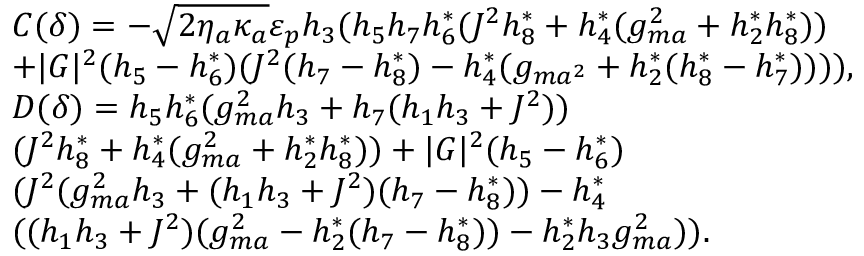<formula> <loc_0><loc_0><loc_500><loc_500>\begin{array} { r l } & { C ( \delta ) = - \sqrt { 2 \eta _ { a } \kappa _ { a } } \varepsilon _ { p } h _ { 3 } ( h _ { 5 } h _ { 7 } h _ { 6 } ^ { * } ( J ^ { 2 } h _ { 8 } ^ { * } + h _ { 4 } ^ { * } ( g _ { m a } ^ { 2 } + h _ { 2 } ^ { * } h _ { 8 } ^ { * } ) ) } \\ & { + | G | ^ { 2 } ( h _ { 5 } - h _ { 6 } ^ { * } ) ( J ^ { 2 } ( h _ { 7 } - h _ { 8 } ^ { * } ) - h _ { 4 } ^ { * } ( g _ { m a ^ { 2 } } + h _ { 2 } ^ { * } ( h _ { 8 } ^ { * } - h _ { 7 } ^ { * } ) ) ) ) , } \\ & { D ( \delta ) = h _ { 5 } h _ { 6 } ^ { * } ( g _ { m a } ^ { 2 } h _ { 3 } + h _ { 7 } ( h _ { 1 } h _ { 3 } + J ^ { 2 } ) ) } \\ & { ( J ^ { 2 } h _ { 8 } ^ { * } + h _ { 4 } ^ { * } ( g _ { m a } ^ { 2 } + h _ { 2 } ^ { * } h _ { 8 } ^ { * } ) ) + | G | ^ { 2 } ( h _ { 5 } - h _ { 6 } ^ { * } ) } \\ & { ( J ^ { 2 } ( g _ { m a } ^ { 2 } h _ { 3 } + ( h _ { 1 } h _ { 3 } + J ^ { 2 } ) ( h _ { 7 } - h _ { 8 } ^ { * } ) ) - h _ { 4 } ^ { * } } \\ & { ( ( h _ { 1 } h _ { 3 } + J ^ { 2 } ) ( g _ { m a } ^ { 2 } - h _ { 2 } ^ { * } ( h _ { 7 } - h _ { 8 } ^ { * } ) ) - h _ { 2 } ^ { * } h _ { 3 } g _ { m a } ^ { 2 } ) ) . } \end{array}</formula> 